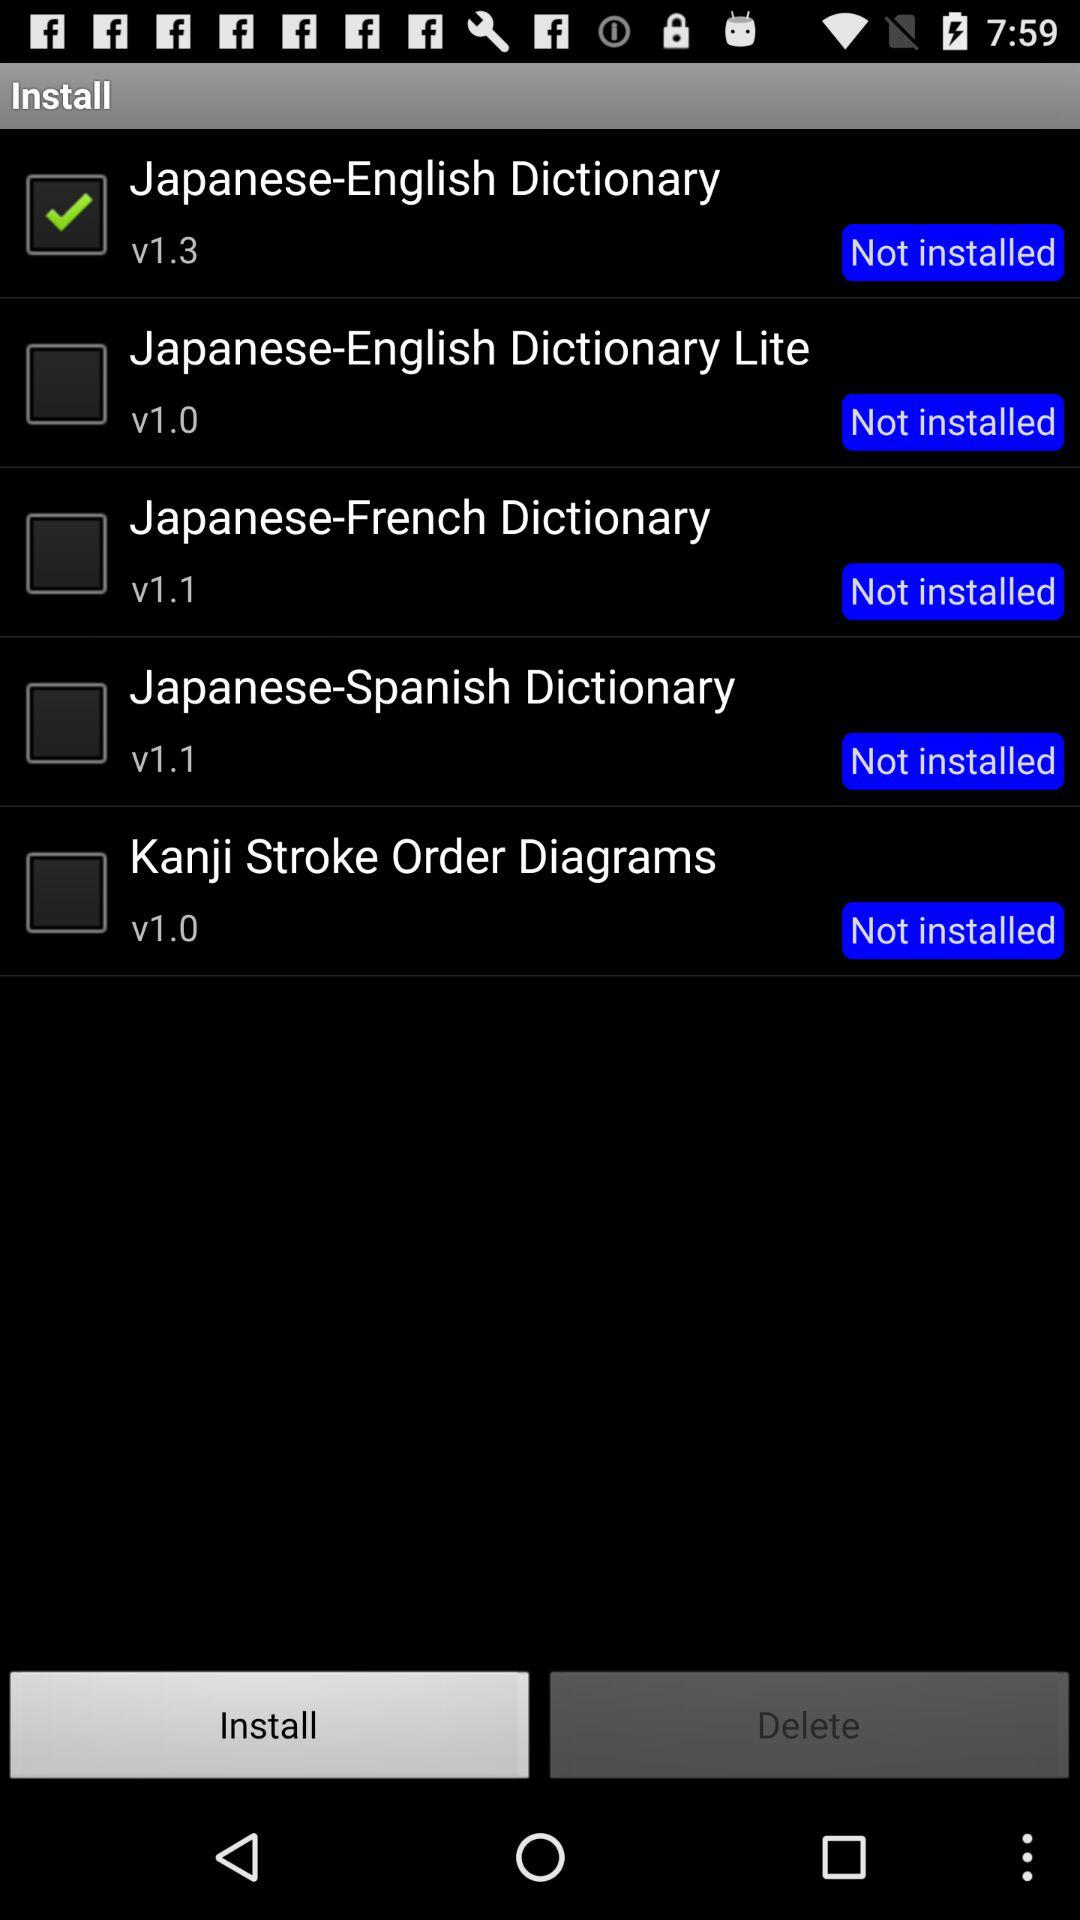How many items have been deleted?
When the provided information is insufficient, respond with <no answer>. <no answer> 